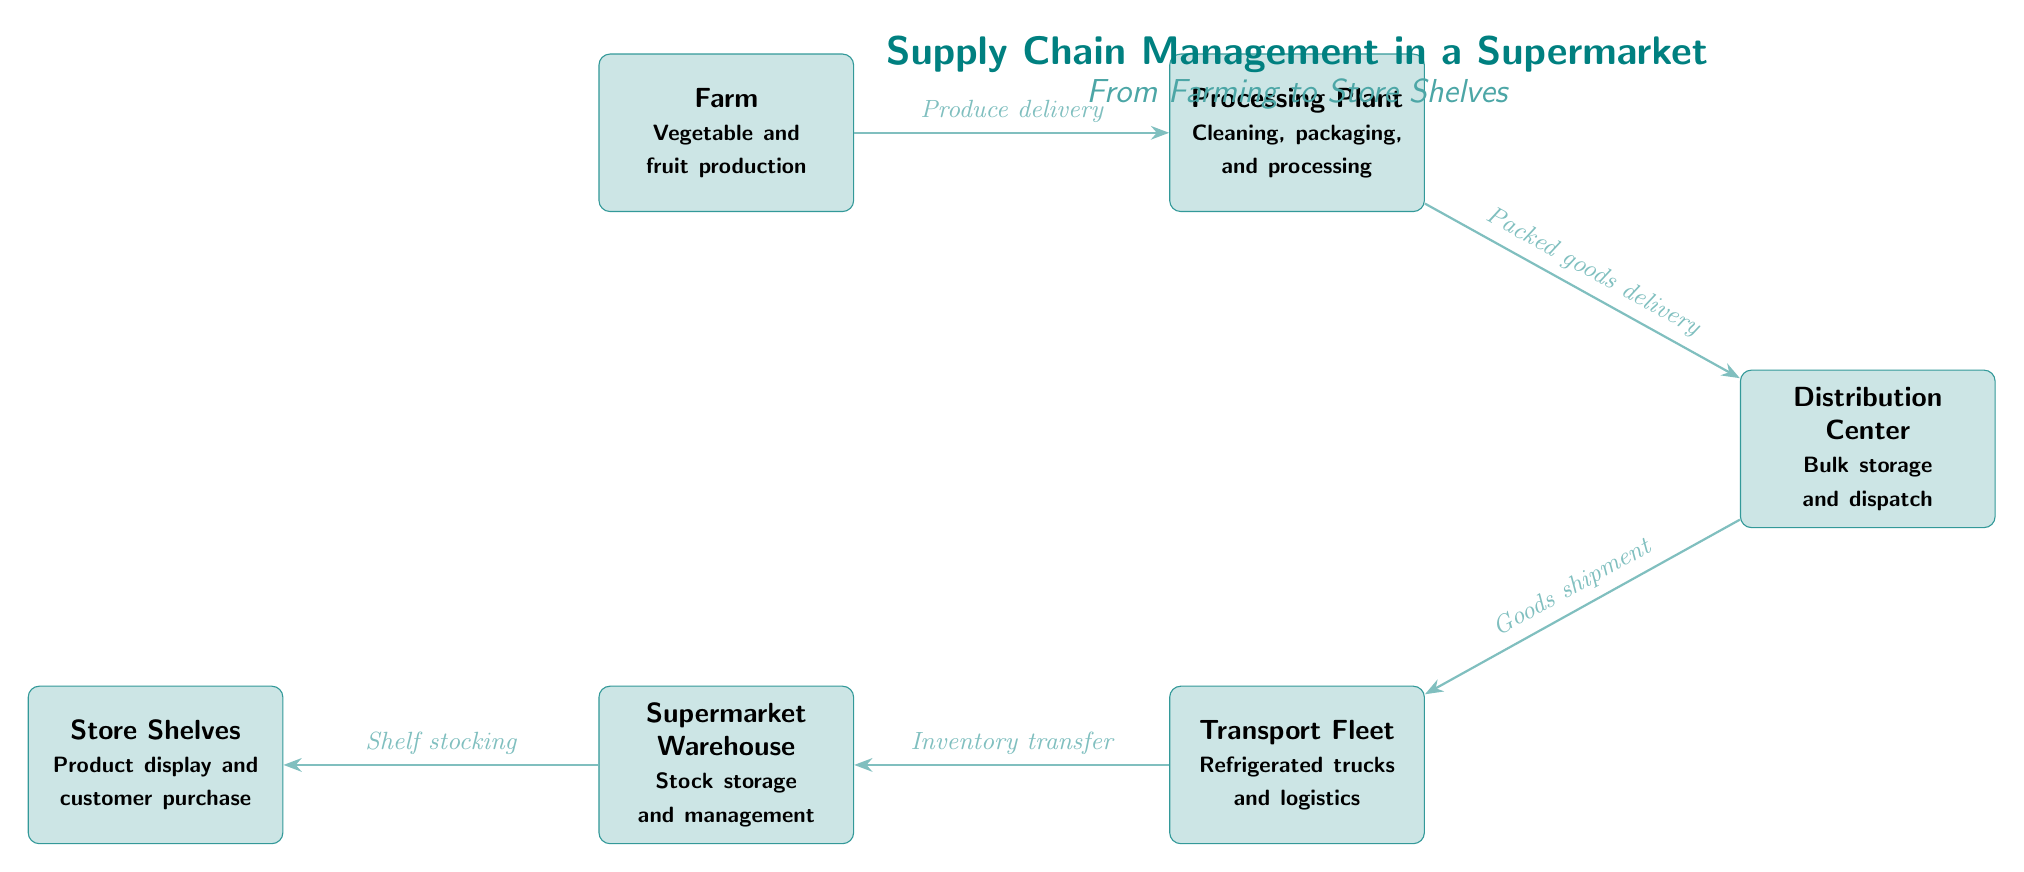What is the first node in the supply chain? The first node in the supply chain is labeled "Farm" which is the starting point for vegetable and fruit production.
Answer: Farm How many nodes are in the diagram? By counting each box representing a stage in the supply chain, there are a total of six nodes: Farm, Processing Plant, Distribution Center, Transport Fleet, Supermarket Warehouse, and Store Shelves.
Answer: 6 What does the arrow from the Processing Plant to the Distribution Center represent? The arrow indicates the flow of goods from the Processing Plant to the Distribution Center, specifically labeled as "Packed goods delivery."
Answer: Packed goods delivery Which stage involves refrigerated trucks? The stage that involves refrigerated trucks is labeled "Transport Fleet," which is responsible for logistics and transportation of goods.
Answer: Transport Fleet What is the last step before the products are placed on the store shelves? The last step before the products are placed on the store shelves is "Shelf stocking," which occurs after inventory transfer.
Answer: Shelf stocking What is the relationship between the Distribution Center and the Transport Fleet? The relationship is that the Distribution Center sends goods for shipment to the Transport Fleet, which manages the logistics of transporting those goods.
Answer: Goods shipment Within the supply chain, which box is positioned to the left of the Supermarket Warehouse? The box positioned to the left of the Supermarket Warehouse is "Transport Fleet," which indicates the flow of goods before entering the warehouse for distribution.
Answer: Transport Fleet Which node specifically mentions the cleaning and packaging of goods? The node that specifically mentions cleaning and packaging of goods is the "Processing Plant."
Answer: Processing Plant What is the purpose of the Distribution Center in the chain? The purpose of the Distribution Center is for bulk storage and dispatch of goods received from the Processing Plant before distribution to stores.
Answer: Bulk storage and dispatch 